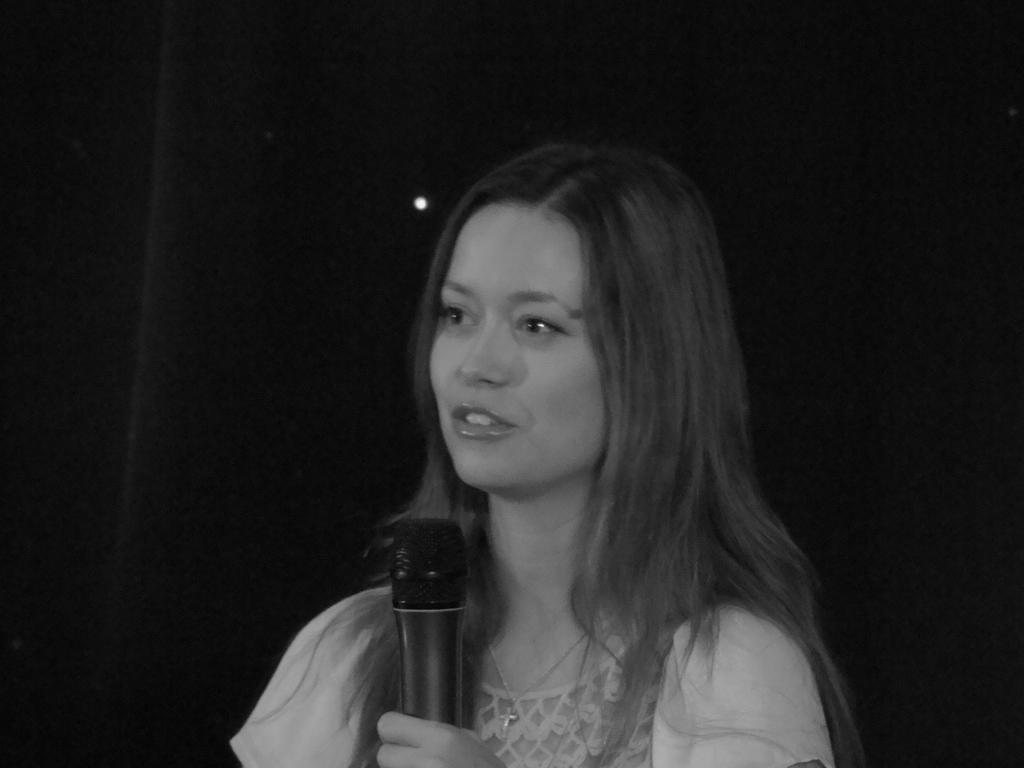Who is the main subject in the image? There is a woman in the image. What is the woman holding in her hand? The woman is holding a microphone in her hand. What is the woman doing in the image? The woman is talking. What is the color scheme of the image? The image is black and white. What type of stone can be seen in the woman's hand in the image? There is no stone present in the image; the woman is holding a microphone. Can you describe the carriage that the woman is sitting in the image? There is no carriage present in the image; the woman is standing. 